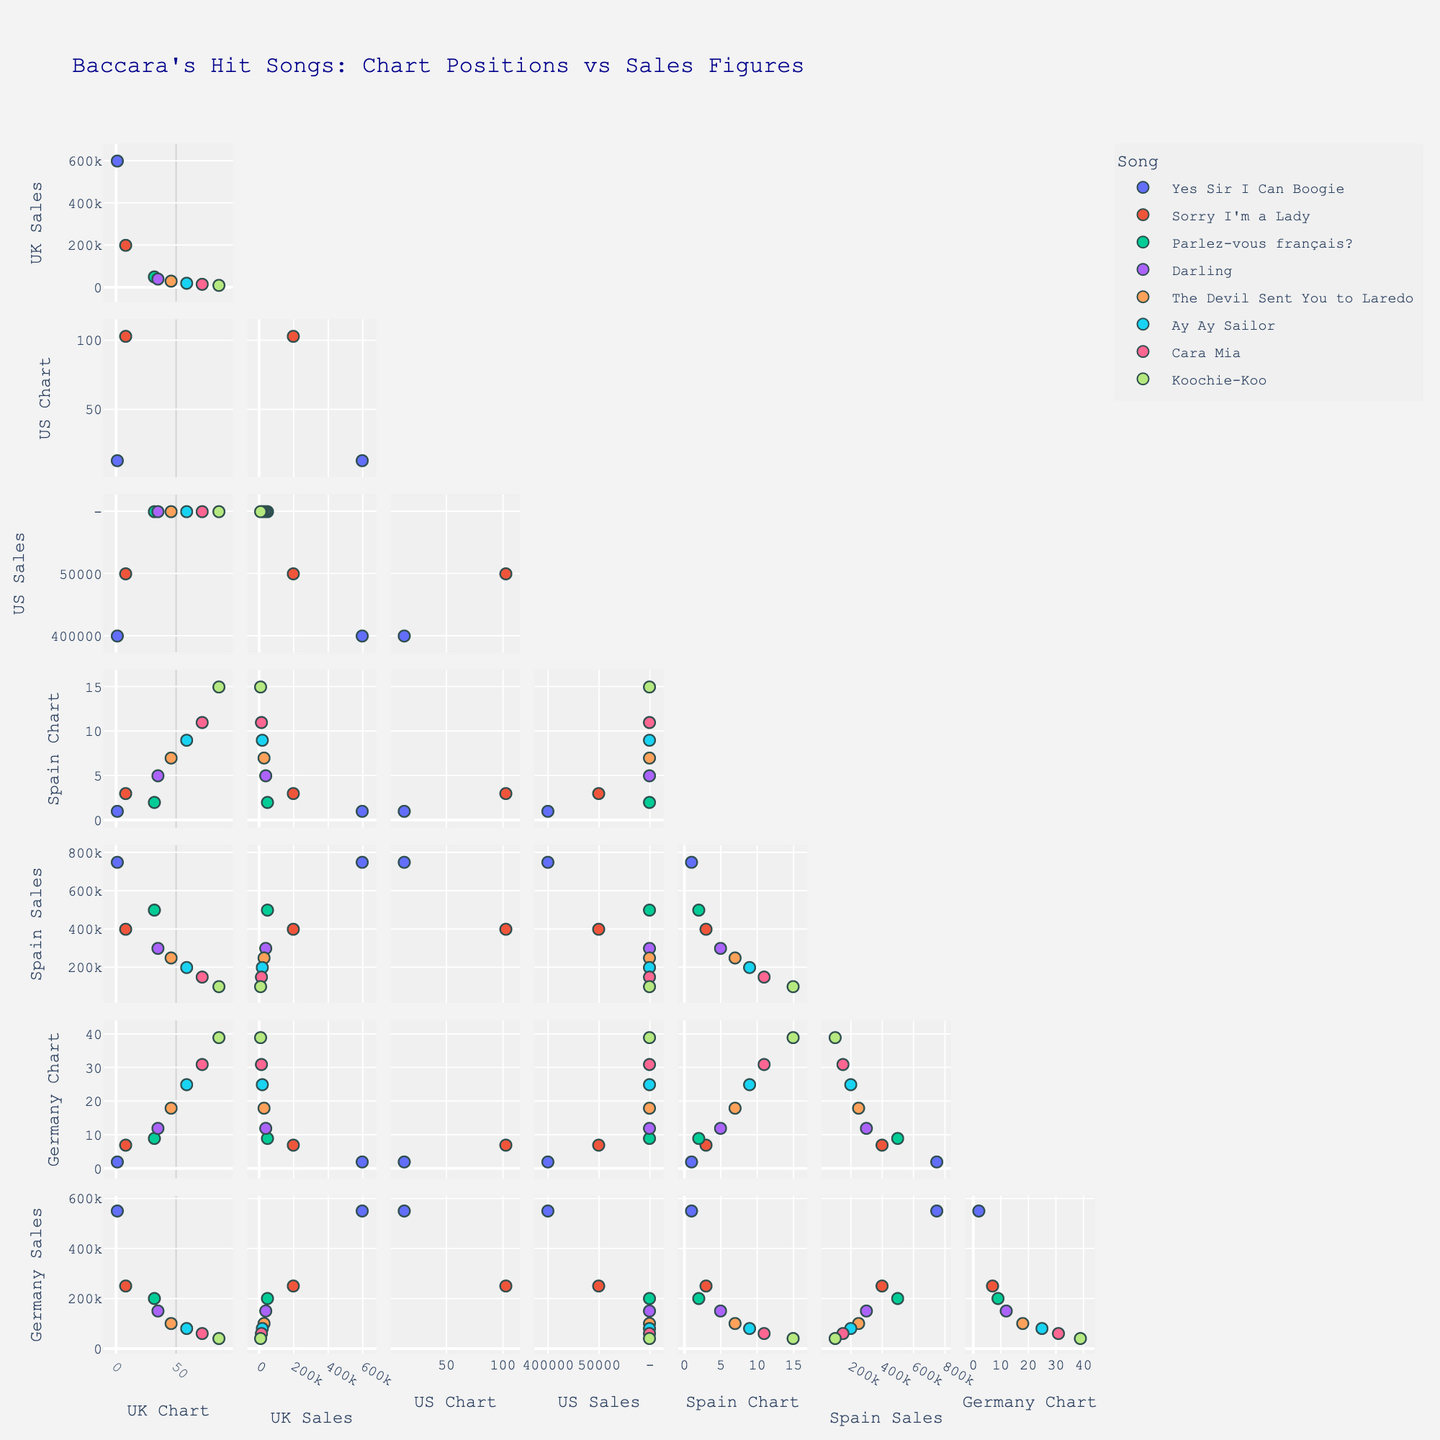How many songs are represented in the scatterplot matrix? Each song is color-coded and has data points in the scatterplot matrix. By counting the unique colors or the legends, we can see there are 8 songs.
Answer: 8 Which country shows the highest correlation between chart positions and sales figures? To find this, look at the diagonals that show scatterplots for each country individually. Observe which one forms a clear positive or negative trend. Spain shows a strong negative correlation between chart positions and sales figures.
Answer: Spain What is the chart position of "Yes Sir I Can Boogie" in Germany? Find the data points labeled "Yes Sir I Can Boogie" and look at its position in the Germany_Chart axis. The position is marked at 2 on the axis.
Answer: 2 Which song has the lowest sales figures in the UK? Look at the UK_Sales scatterplot and identify the data point with the lowest value, then check which song that point corresponds to by its label. "Koochie-Koo" has the lowest sales figure in the UK.
Answer: Koochie-Koo Is there an inverse relationship between US Chart positions and US Sales figures for Baccara’s songs? Look at the scatterplot between US_Chart and US_Sales. If higher sales correspond to lower (better) chart positions and vice versa, there is an inverse relationship. The scatterplot indicates an inverse relationship.
Answer: Yes What's the average sales figure for “Sorry I'm a Lady” across all countries? Identify the sales figures for "Sorry I'm a Lady" in each country: UK (200,000), US (50,000), Spain (400,000), and Germany (250,000). Calculate the average: (200000 + 50000 + 400000 + 250000) / 4.
Answer: 225,000 Which song has the largest discrepancy between its highest and lowest chart positions across different countries? Find the highest and lowest chart positions of each song across countries and calculate the discrepancy. "Yes Sir I Can Boogie" has the largest difference between 1 (UK) and 13 (US).
Answer: Yes Sir I Can Boogie What is the difference in sales figures between "Parlez-vous français?" in Spain and Germany? Identify the sales figures for "Parlez-vous français?" in Spain (500,000) and Germany (200,000), then find the difference: 500,000 - 200,000.
Answer: 300,000 Which song has the best overall chart position in Spain? Look at the Spain_Chart axis and identify the song with the lowest number (since lower is better). "Yes Sir I Can Boogie" and "Parlez-vous français?" both have a chart position of 1 in Spain.
Answer: Yes Sir I Can Boogie, Parlez-vous français? How many songs have sales figures less than 100,000 in Germany? Look at the Germany_Sales scatterplot and count the data points with sales figures below 100,000. Two songs ("Ay Ay Sailor" and "Koochie-Koo") have sales figures below 100,000 in Germany.
Answer: 2 